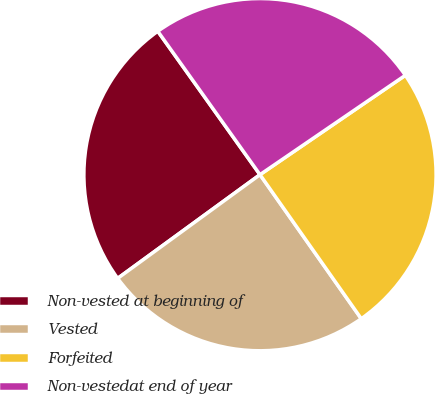Convert chart to OTSL. <chart><loc_0><loc_0><loc_500><loc_500><pie_chart><fcel>Non-vested at beginning of<fcel>Vested<fcel>Forfeited<fcel>Non-vestedat end of year<nl><fcel>25.17%<fcel>24.73%<fcel>24.79%<fcel>25.31%<nl></chart> 